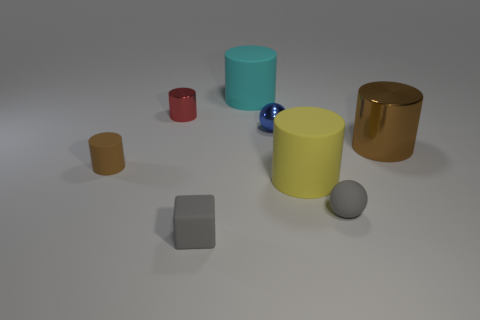Subtract all gray balls. How many balls are left? 1 Subtract all small cylinders. How many cylinders are left? 3 Add 1 tiny yellow shiny spheres. How many objects exist? 9 Subtract all cylinders. How many objects are left? 3 Subtract all purple balls. How many red cylinders are left? 1 Subtract all big metal objects. Subtract all metallic cylinders. How many objects are left? 5 Add 4 yellow things. How many yellow things are left? 5 Add 3 red metallic objects. How many red metallic objects exist? 4 Subtract 0 brown balls. How many objects are left? 8 Subtract 4 cylinders. How many cylinders are left? 1 